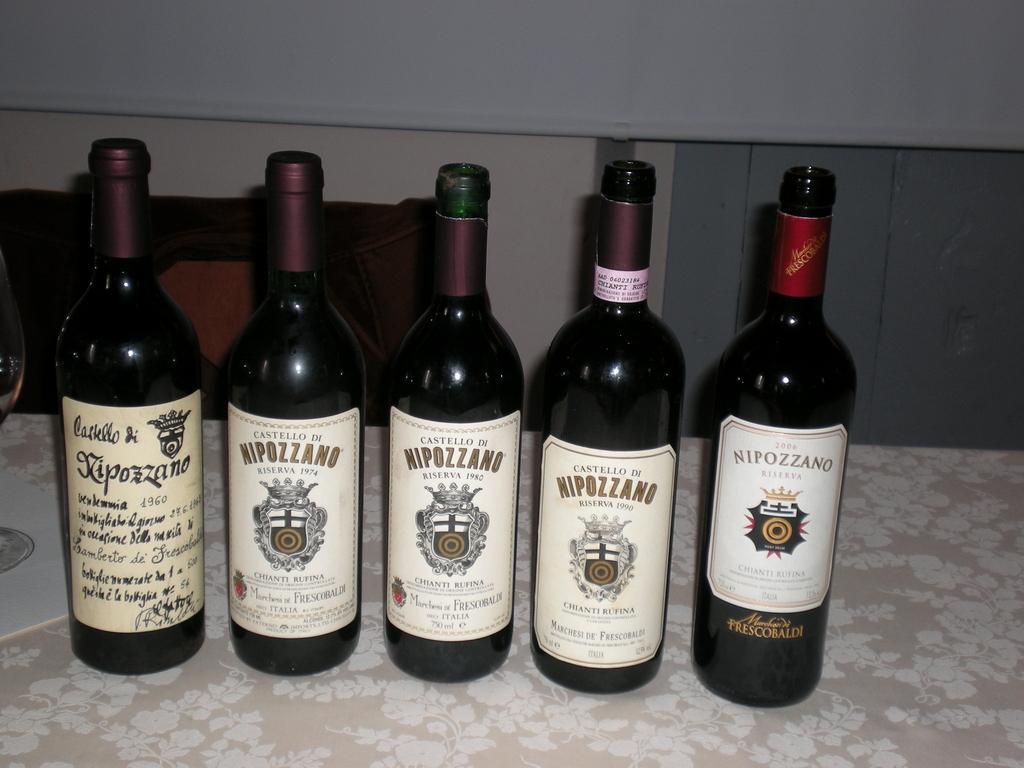Please provide a concise description of this image. In this picture I see 5 bottles in front, on which I see labels and I see something is written on the labels and these bottles are on a surface which is of white and cream in color. 